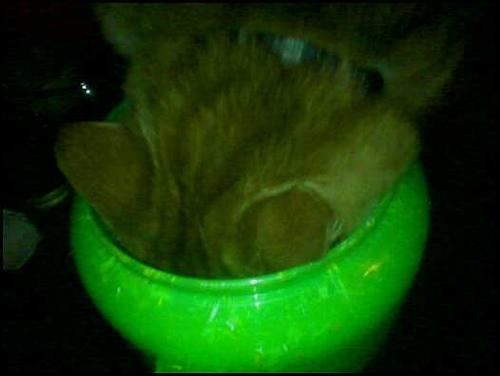Inform where the visual focus should be directed to understand the main activity and the objects involved. Focus on the yellow cat with its head in the green bowl, eating. Assess the sentiment or emotion conveyed by the image. The image conveys a sense of curiosity and contentment, as the cat is enjoying its meal in the green bowl. Provide a brief description of the major object and its action in the picture. A yellow cat is eating from a green bowl with its head inside. Mention the prominent action taking place in the image and the object involved. A cat is eating from a green bowl, with its head inside it. Describe the accessory worn by the animal in the image. The cat is wearing a silver collar with a black clip on the right. Analyze the object interaction in the image involving the living being. The cat is interacting with the green bowl by having its head inside and eating from it. Identify and count the main objects in the image. There's 1 cat, 1 green bowl, and some recognisable parts of the cat like ears and collar. Elaborate the main action happening in the image, along with the essential object and its color, in a detailed manner. A yellow cat is putting its head inside a green bowl and eating, with both its left and right ears visible in the picture. What is the color of the bowl the cat has its face in? The bowl is green. What are the two primary visible body parts of the cat in the image? The left and right ears of the cat are visible. Express the cat's current activity. Eating Do you see a dog instead of a cat in the image? No, it's not mentioned in the image. Does the image show the cat's entire body or just a portion? Just a portion, mainly the head and upper body Do you notice the red collar on the cat? The collar is described as silver in the image, not red. What is the position of the black clip on the cat's collar? On the right side List any facial features of the cat that are visible in the image. Ears, the back of the head Can you describe the cat's collar and any accessories it might have? The cat is wearing a silver collar with a black clip on the right side Create a short story inspired by the image. Once upon a time, a curious yellow cat named Whiskers found a mysterious green bowl in the kitchen. Whiskers decided to explore the contents of the bowl and discovered a delicious treat. Soon, the cat became popular in the neighborhood for its adventurous spirit. How many ears of the cat are visible and what are their positions? Two, left ear is near the top-front of the head and the right ear is tilted to the side What type of dish is the cat eating from? A green bowl Which object has a reflection in the image? The green bowl Is there a purple bowl the cat's face is in? The bowl is described as green in the image, not purple. Describe the cat's appearance and actions in this image. A yellow cat is eating with its head inside a green bowl, and it's wearing a silver collar. Refer to the image and describe if any other objects are present besides the cat and the bowl. A gold jar lid on the left and a white paper next to it Is the jar that the cat is eating from green or blue? Green Determine any significant event happening in the image. A cat is eating out of a green bowl Read the text present in the image, if any. No text present Refer to the cat's ear and tell its position. The left ear is on the top-front of the head and the right ear is tilted to the side. Can you see the blue jar the cat is eating from? The jar is described as green in the image, not blue. Identify the main colors visible in the image. Green, yellow, white, black Explain the relationship between the cat and the bowl in the diagram. The cat has its head inside the bowl while eating 